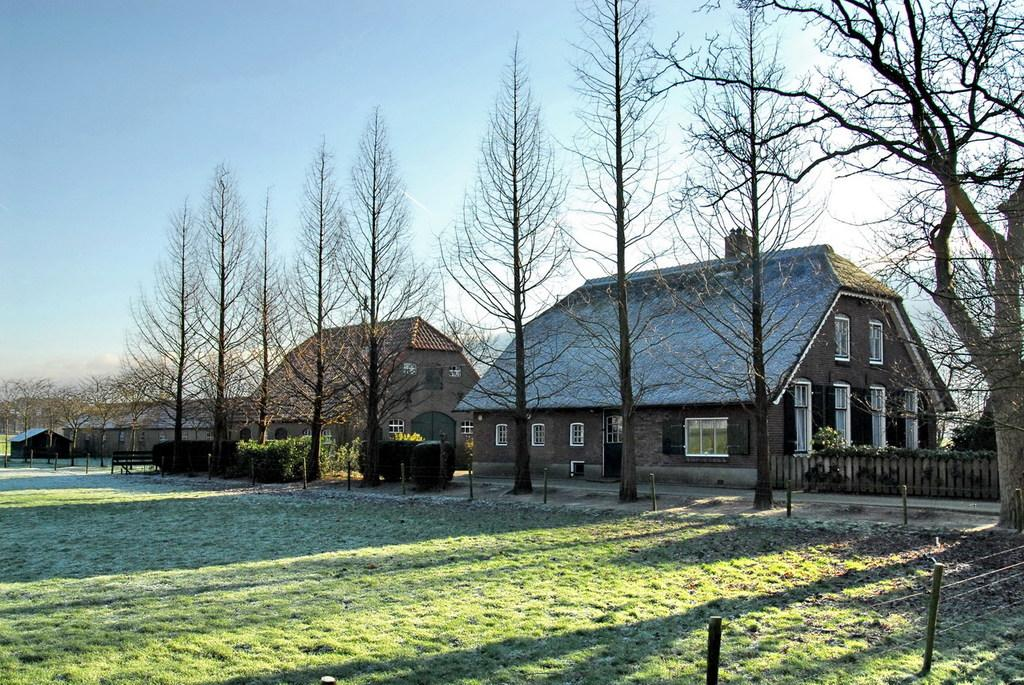What type of structures can be seen in the image? There are houses in the image. What type of vegetation is present in the image? There are trees in the image. What type of ground cover is visible in the image? There is grass in the image. What is the condition of the sky in the image? The sky is clear in the image. How many beads are hanging from the trees in the image? There are no beads hanging from the trees in the image. 